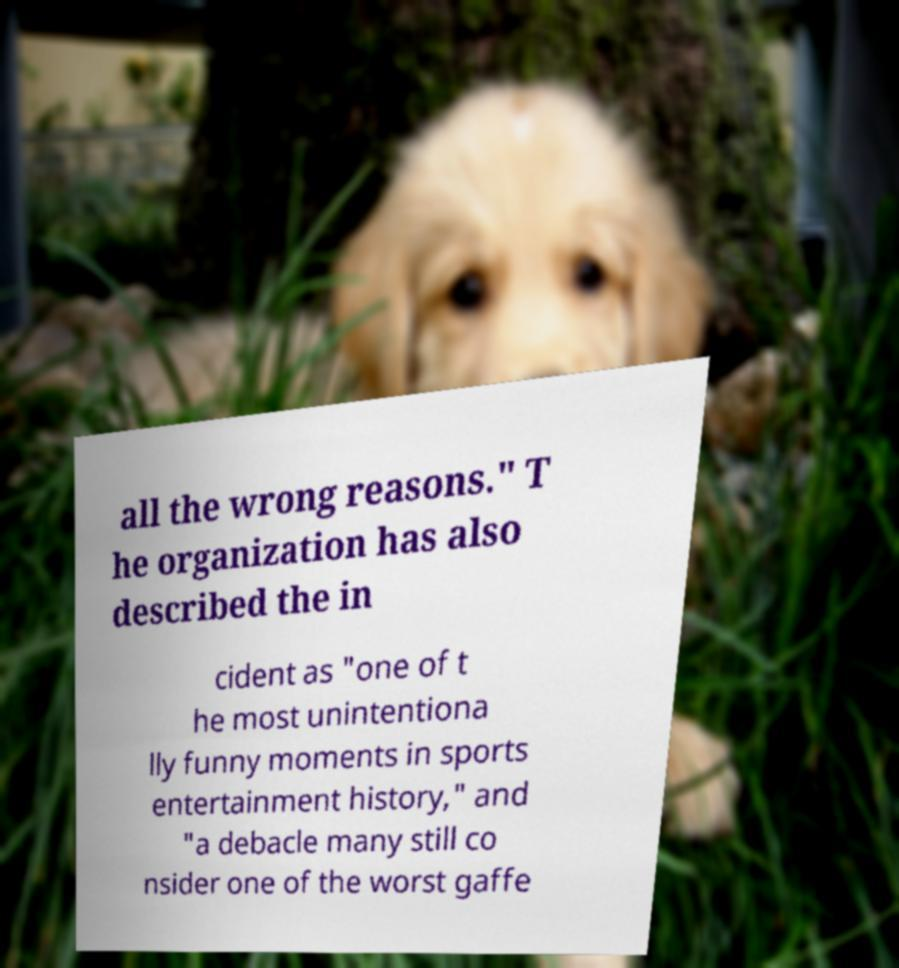Could you extract and type out the text from this image? all the wrong reasons." T he organization has also described the in cident as "one of t he most unintentiona lly funny moments in sports entertainment history," and "a debacle many still co nsider one of the worst gaffe 